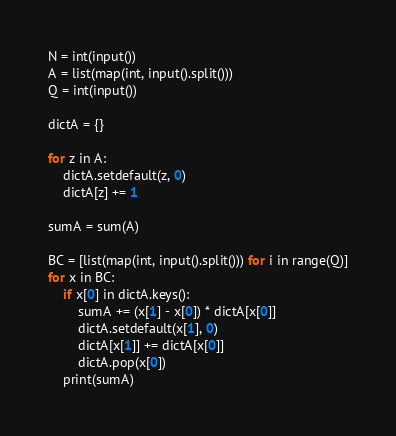Convert code to text. <code><loc_0><loc_0><loc_500><loc_500><_Python_>N = int(input())
A = list(map(int, input().split()))
Q = int(input())

dictA = {}

for z in A:
    dictA.setdefault(z, 0)
    dictA[z] += 1

sumA = sum(A)

BC = [list(map(int, input().split())) for i in range(Q)]
for x in BC:
    if x[0] in dictA.keys():
        sumA += (x[1] - x[0]) * dictA[x[0]]
        dictA.setdefault(x[1], 0)
        dictA[x[1]] += dictA[x[0]]
        dictA.pop(x[0])
    print(sumA)
</code> 